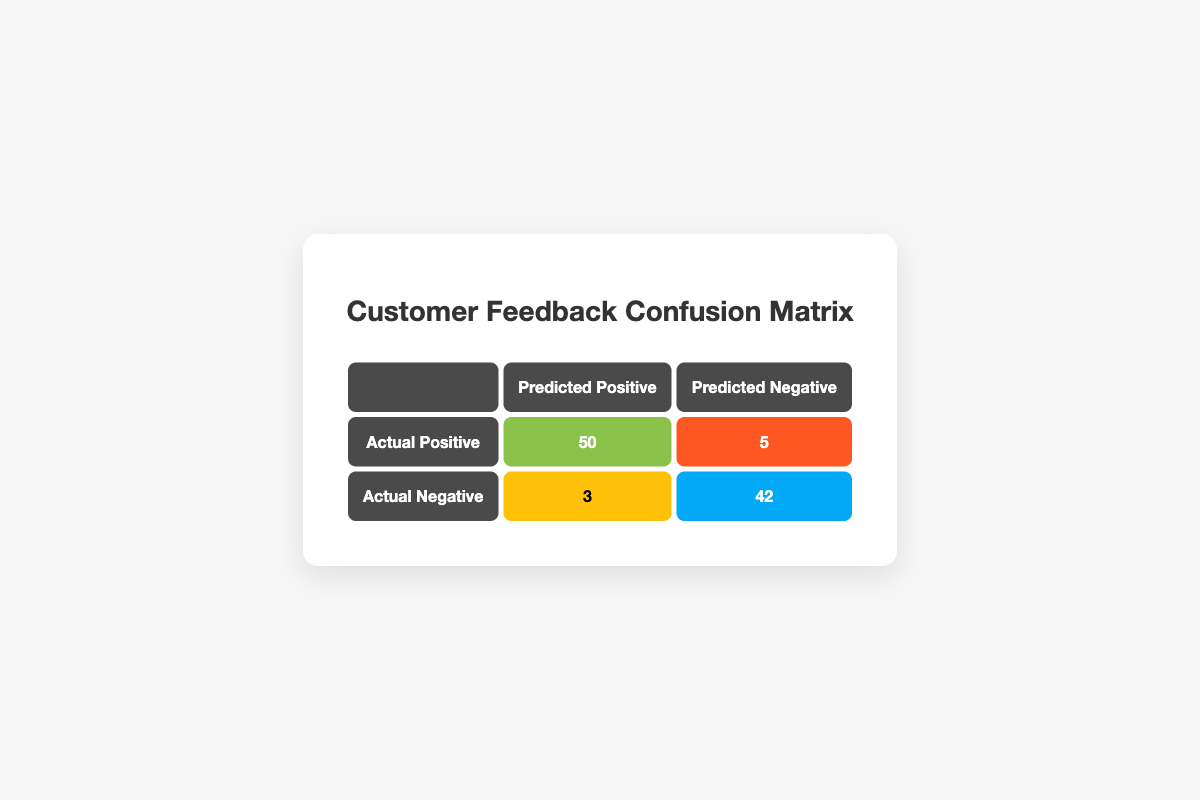What is the number of true positive predictions? The true positive predictions are those where the actual feedback was positive and the predicted feedback was also positive. According to the table, this value is listed in the cell corresponding to Actual Positive and Predicted Positive, which is 50.
Answer: 50 What is the number of false negative predictions? False negative predictions occur when the actual feedback was positive, but it was predicted as negative. This is found in the cell for Actual Positive and Predicted Negative, which shows a count of 5.
Answer: 5 How many total negative feedback counts are predicted? To find the total predicted negative feedback, I add the values in the Predicted Negative column. This includes false negative (5) and true negative (42) predictions: 5 + 42 = 47.
Answer: 47 Is the number of false positives greater than false negatives? False positives are when the actual feedback is negative but predicted as positive, with a count of 3. False negatives have a count of 5. Since 3 is not greater than 5, the statement is false.
Answer: No What is the total count of actual negative feedbacks? The total count of actual negative feedbacks consists of both true negatives and false positives. Therefore, I sum the values in the Actual Negative row: 3 (false positive) + 42 (true negative) = 45.
Answer: 45 What percentage of the total predictions were true positives? To calculate the percentage of true positives, I first need to find the total predictions: 50 (true positive) + 5 (false negative) + 3 (false positive) + 42 (true negative) = 100. The percentage of true positives is (50/100) * 100 = 50%.
Answer: 50% If we focus only on the predicted positives, what is the ratio of true positives to false positives? The true positives are counted as 50 and the false positives are counted as 3. The ratio of true positives to false positives is calculated: 50:3, which simplifies to approximately 16.67:1.
Answer: 16.67:1 How many more actual negative cases were there compared to false positives? To determine how many more actual negative cases there are, I first find the actual negative count, which is 45, and subtract the false positives (3): 45 - 3 = 42.
Answer: 42 What is the total count of actual positive feedback? The total count of actual positive feedback includes true positives and false negatives. Summing these values gives me 50 (true positive) + 5 (false negative) = 55.
Answer: 55 